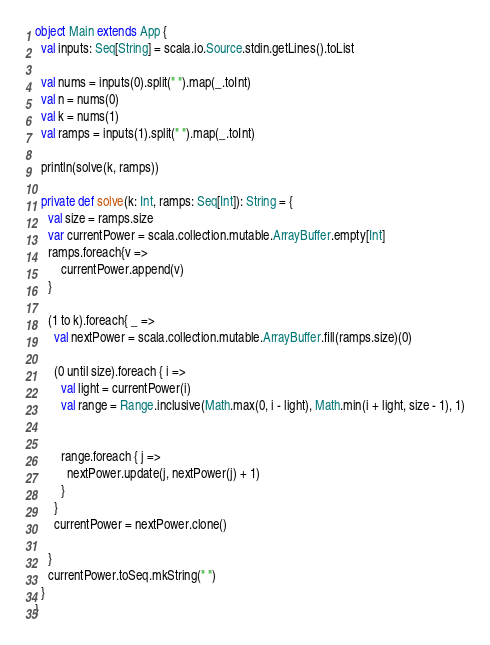<code> <loc_0><loc_0><loc_500><loc_500><_Scala_>object Main extends App {
  val inputs: Seq[String] = scala.io.Source.stdin.getLines().toList
  
  val nums = inputs(0).split(" ").map(_.toInt)
  val n = nums(0)
  val k = nums(1)
  val ramps = inputs(1).split(" ").map(_.toInt)

  println(solve(k, ramps))

  private def solve(k: Int, ramps: Seq[Int]): String = {
    val size = ramps.size
    var currentPower = scala.collection.mutable.ArrayBuffer.empty[Int]
    ramps.foreach{v =>
        currentPower.append(v)
    }

    (1 to k).foreach{ _ =>
      val nextPower = scala.collection.mutable.ArrayBuffer.fill(ramps.size)(0)

      (0 until size).foreach { i =>
        val light = currentPower(i)
        val range = Range.inclusive(Math.max(0, i - light), Math.min(i + light, size - 1), 1)


        range.foreach { j =>
          nextPower.update(j, nextPower(j) + 1)
        }
      }
      currentPower = nextPower.clone()
     
    }
    currentPower.toSeq.mkString(" ")
  }
}</code> 